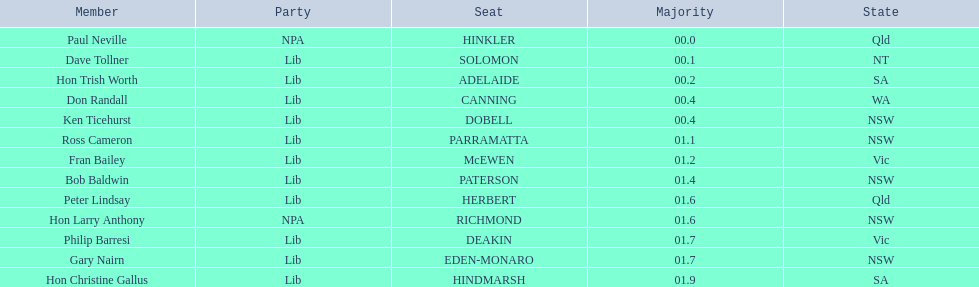What state does hinkler belong too? Qld. Could you parse the entire table? {'header': ['Member', 'Party', 'Seat', 'Majority', 'State'], 'rows': [['Paul Neville', 'NPA', 'HINKLER', '00.0', 'Qld'], ['Dave Tollner', 'Lib', 'SOLOMON', '00.1', 'NT'], ['Hon Trish Worth', 'Lib', 'ADELAIDE', '00.2', 'SA'], ['Don Randall', 'Lib', 'CANNING', '00.4', 'WA'], ['Ken Ticehurst', 'Lib', 'DOBELL', '00.4', 'NSW'], ['Ross Cameron', 'Lib', 'PARRAMATTA', '01.1', 'NSW'], ['Fran Bailey', 'Lib', 'McEWEN', '01.2', 'Vic'], ['Bob Baldwin', 'Lib', 'PATERSON', '01.4', 'NSW'], ['Peter Lindsay', 'Lib', 'HERBERT', '01.6', 'Qld'], ['Hon Larry Anthony', 'NPA', 'RICHMOND', '01.6', 'NSW'], ['Philip Barresi', 'Lib', 'DEAKIN', '01.7', 'Vic'], ['Gary Nairn', 'Lib', 'EDEN-MONARO', '01.7', 'NSW'], ['Hon Christine Gallus', 'Lib', 'HINDMARSH', '01.9', 'SA']]} What is the majority of difference between sa and qld? 01.9. 